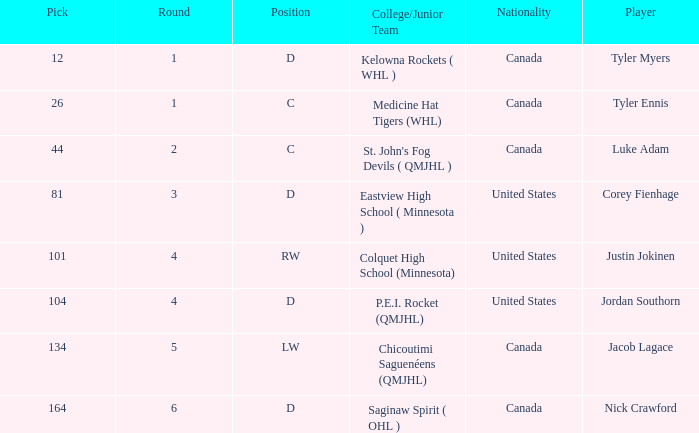What is the average round of the rw position player from the United States? 4.0. 